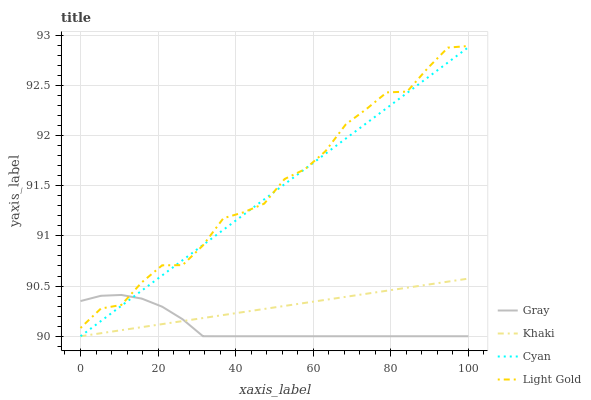Does Gray have the minimum area under the curve?
Answer yes or no. Yes. Does Light Gold have the maximum area under the curve?
Answer yes or no. Yes. Does Khaki have the minimum area under the curve?
Answer yes or no. No. Does Khaki have the maximum area under the curve?
Answer yes or no. No. Is Cyan the smoothest?
Answer yes or no. Yes. Is Light Gold the roughest?
Answer yes or no. Yes. Is Khaki the smoothest?
Answer yes or no. No. Is Khaki the roughest?
Answer yes or no. No. Does Gray have the lowest value?
Answer yes or no. Yes. Does Light Gold have the lowest value?
Answer yes or no. No. Does Light Gold have the highest value?
Answer yes or no. Yes. Does Khaki have the highest value?
Answer yes or no. No. Is Khaki less than Light Gold?
Answer yes or no. Yes. Is Light Gold greater than Khaki?
Answer yes or no. Yes. Does Cyan intersect Light Gold?
Answer yes or no. Yes. Is Cyan less than Light Gold?
Answer yes or no. No. Is Cyan greater than Light Gold?
Answer yes or no. No. Does Khaki intersect Light Gold?
Answer yes or no. No. 